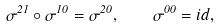Convert formula to latex. <formula><loc_0><loc_0><loc_500><loc_500>\sigma ^ { 2 1 } \circ \sigma ^ { 1 0 } = \sigma ^ { 2 0 } , \quad \sigma ^ { 0 0 } = i d ,</formula> 